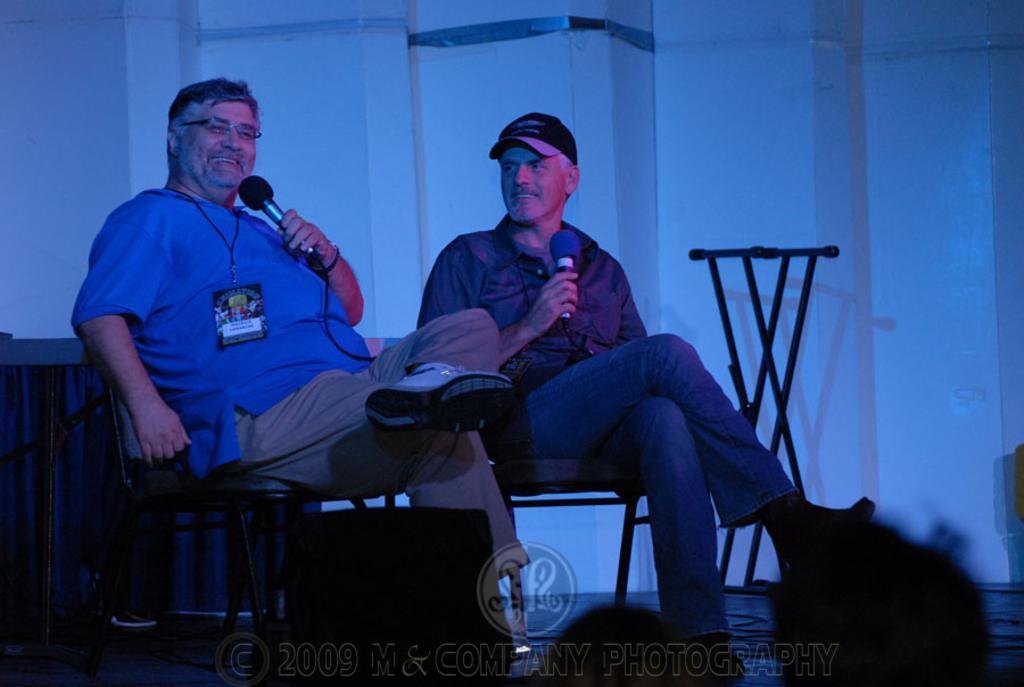How would you summarize this image in a sentence or two? This picture shows a two men sitting in the chair and holding mics in their hands. In the background there is a wall. 